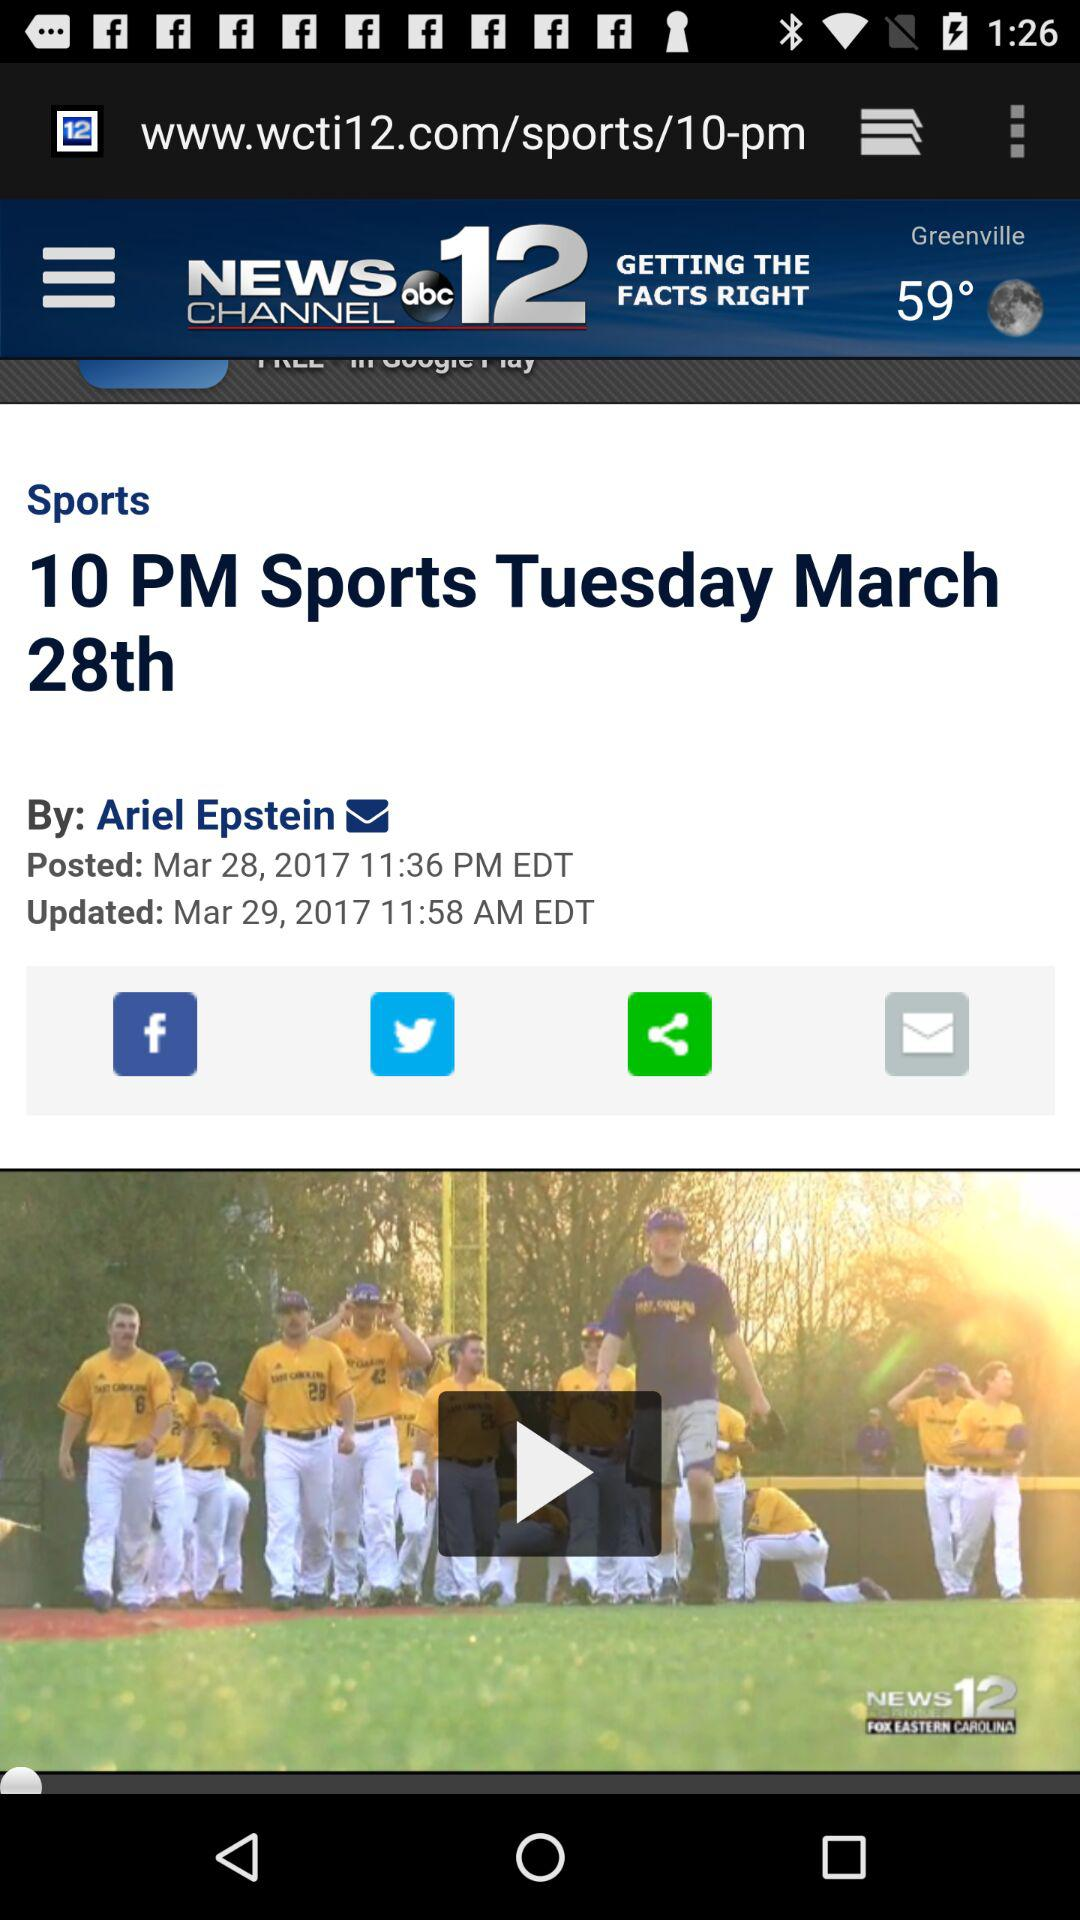Who posted the sports news? The sports news was posted by Ariel Epstein. 